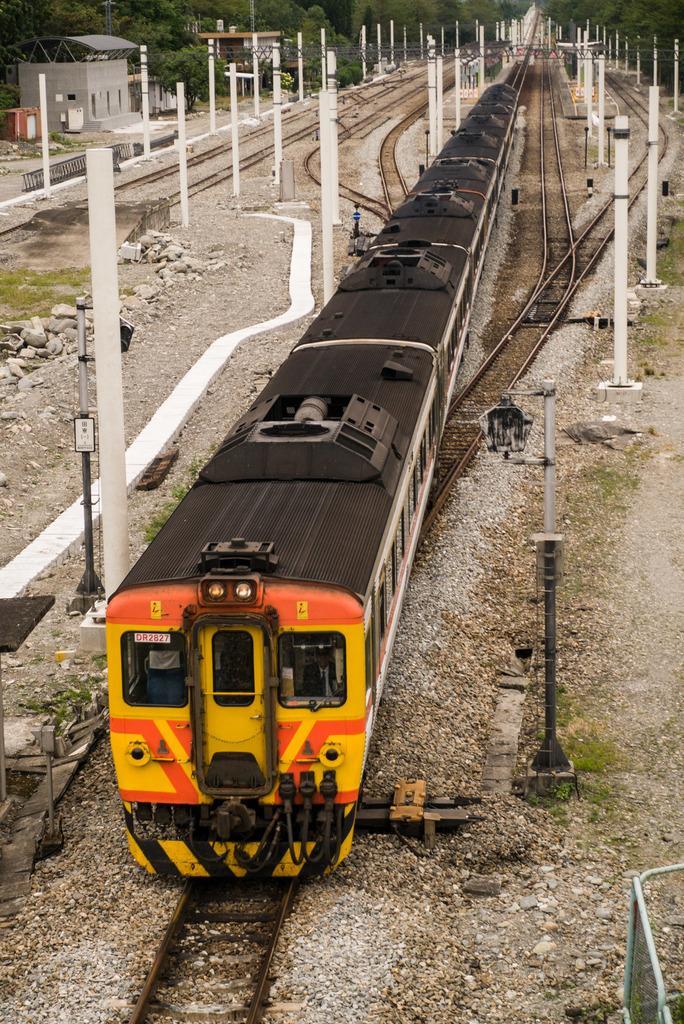How would you summarize this image in a sentence or two? In this image I can see few railway tracks and on it I can see a train. I can also see number of poles, number of trees, a shack and I can also see grass. 